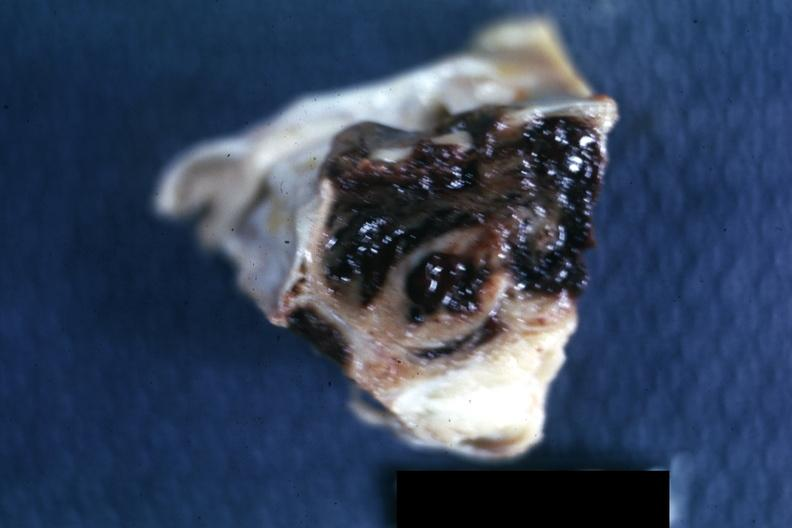what is present?
Answer the question using a single word or phrase. Pituitary 